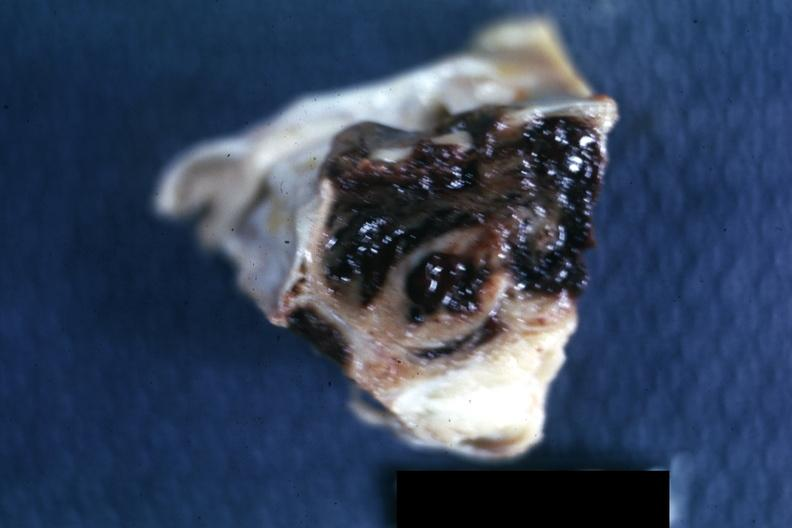what is present?
Answer the question using a single word or phrase. Pituitary 